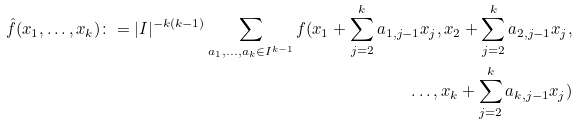<formula> <loc_0><loc_0><loc_500><loc_500>\hat { f } ( x _ { 1 } , \dots , x _ { k } ) \colon = | I | ^ { - k ( k - 1 ) } \sum _ { a _ { 1 } , \dots , a _ { k } \in I ^ { k - 1 } } f ( x _ { 1 } + \sum _ { j = 2 } ^ { k } a _ { 1 , j - 1 } x _ { j } , x _ { 2 } + \sum _ { j = 2 } ^ { k } a _ { 2 , j - 1 } x _ { j } , \\ \dots , x _ { k } + \sum _ { j = 2 } ^ { k } a _ { k , j - 1 } x _ { j } )</formula> 